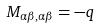<formula> <loc_0><loc_0><loc_500><loc_500>M _ { \alpha \beta , \alpha \beta } = - q</formula> 